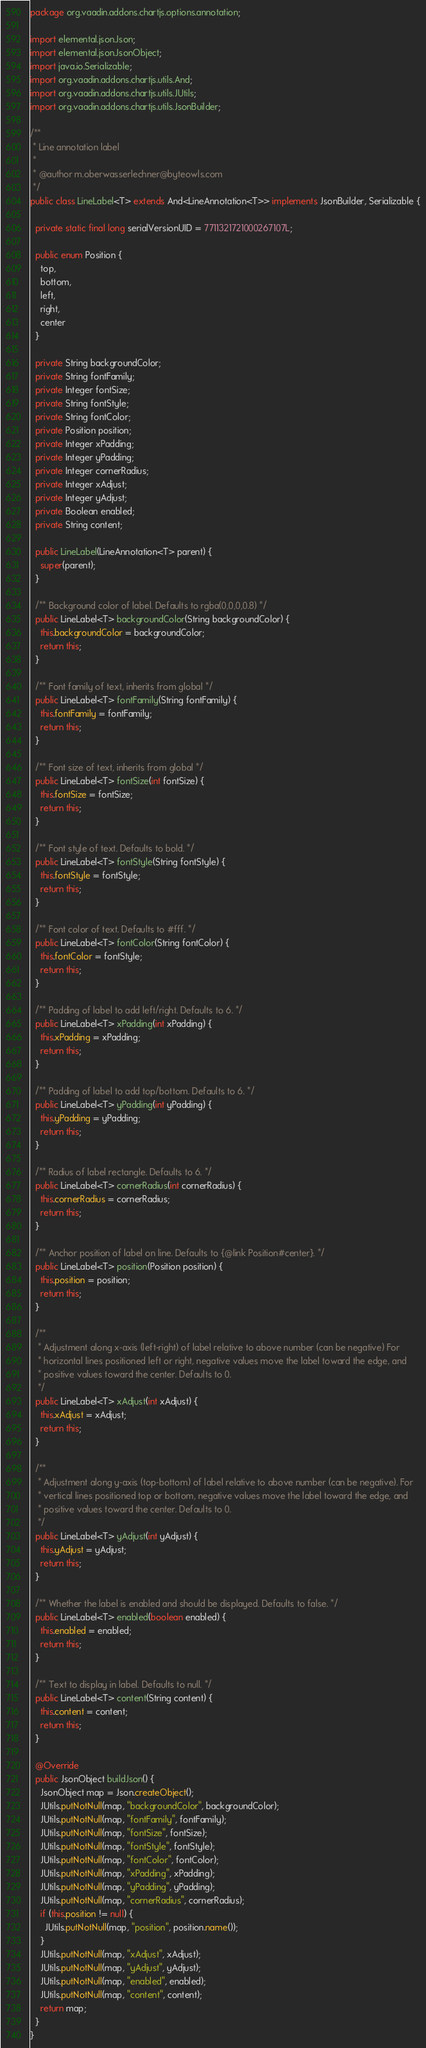Convert code to text. <code><loc_0><loc_0><loc_500><loc_500><_Java_>package org.vaadin.addons.chartjs.options.annotation;

import elemental.json.Json;
import elemental.json.JsonObject;
import java.io.Serializable;
import org.vaadin.addons.chartjs.utils.And;
import org.vaadin.addons.chartjs.utils.JUtils;
import org.vaadin.addons.chartjs.utils.JsonBuilder;

/**
 * Line annotation label
 *
 * @author m.oberwasserlechner@byteowls.com
 */
public class LineLabel<T> extends And<LineAnnotation<T>> implements JsonBuilder, Serializable {

  private static final long serialVersionUID = 7711321721000267107L;

  public enum Position {
    top,
    bottom,
    left,
    right,
    center
  }

  private String backgroundColor;
  private String fontFamily;
  private Integer fontSize;
  private String fontStyle;
  private String fontColor;
  private Position position;
  private Integer xPadding;
  private Integer yPadding;
  private Integer cornerRadius;
  private Integer xAdjust;
  private Integer yAdjust;
  private Boolean enabled;
  private String content;

  public LineLabel(LineAnnotation<T> parent) {
    super(parent);
  }

  /** Background color of label. Defaults to rgba(0,0,0,0.8) */
  public LineLabel<T> backgroundColor(String backgroundColor) {
    this.backgroundColor = backgroundColor;
    return this;
  }

  /** Font family of text, inherits from global */
  public LineLabel<T> fontFamily(String fontFamily) {
    this.fontFamily = fontFamily;
    return this;
  }

  /** Font size of text, inherits from global */
  public LineLabel<T> fontSize(int fontSize) {
    this.fontSize = fontSize;
    return this;
  }

  /** Font style of text. Defaults to bold. */
  public LineLabel<T> fontStyle(String fontStyle) {
    this.fontStyle = fontStyle;
    return this;
  }

  /** Font color of text. Defaults to #fff. */
  public LineLabel<T> fontColor(String fontColor) {
    this.fontColor = fontStyle;
    return this;
  }

  /** Padding of label to add left/right. Defaults to 6. */
  public LineLabel<T> xPadding(int xPadding) {
    this.xPadding = xPadding;
    return this;
  }

  /** Padding of label to add top/bottom. Defaults to 6. */
  public LineLabel<T> yPadding(int yPadding) {
    this.yPadding = yPadding;
    return this;
  }

  /** Radius of label rectangle. Defaults to 6. */
  public LineLabel<T> cornerRadius(int cornerRadius) {
    this.cornerRadius = cornerRadius;
    return this;
  }

  /** Anchor position of label on line. Defaults to {@link Position#center}. */
  public LineLabel<T> position(Position position) {
    this.position = position;
    return this;
  }

  /**
   * Adjustment along x-axis (left-right) of label relative to above number (can be negative) For
   * horizontal lines positioned left or right, negative values move the label toward the edge, and
   * positive values toward the center. Defaults to 0.
   */
  public LineLabel<T> xAdjust(int xAdjust) {
    this.xAdjust = xAdjust;
    return this;
  }

  /**
   * Adjustment along y-axis (top-bottom) of label relative to above number (can be negative). For
   * vertical lines positioned top or bottom, negative values move the label toward the edge, and
   * positive values toward the center. Defaults to 0.
   */
  public LineLabel<T> yAdjust(int yAdjust) {
    this.yAdjust = yAdjust;
    return this;
  }

  /** Whether the label is enabled and should be displayed. Defaults to false. */
  public LineLabel<T> enabled(boolean enabled) {
    this.enabled = enabled;
    return this;
  }

  /** Text to display in label. Defaults to null. */
  public LineLabel<T> content(String content) {
    this.content = content;
    return this;
  }

  @Override
  public JsonObject buildJson() {
    JsonObject map = Json.createObject();
    JUtils.putNotNull(map, "backgroundColor", backgroundColor);
    JUtils.putNotNull(map, "fontFamily", fontFamily);
    JUtils.putNotNull(map, "fontSize", fontSize);
    JUtils.putNotNull(map, "fontStyle", fontStyle);
    JUtils.putNotNull(map, "fontColor", fontColor);
    JUtils.putNotNull(map, "xPadding", xPadding);
    JUtils.putNotNull(map, "yPadding", yPadding);
    JUtils.putNotNull(map, "cornerRadius", cornerRadius);
    if (this.position != null) {
      JUtils.putNotNull(map, "position", position.name());
    }
    JUtils.putNotNull(map, "xAdjust", xAdjust);
    JUtils.putNotNull(map, "yAdjust", yAdjust);
    JUtils.putNotNull(map, "enabled", enabled);
    JUtils.putNotNull(map, "content", content);
    return map;
  }
}
</code> 